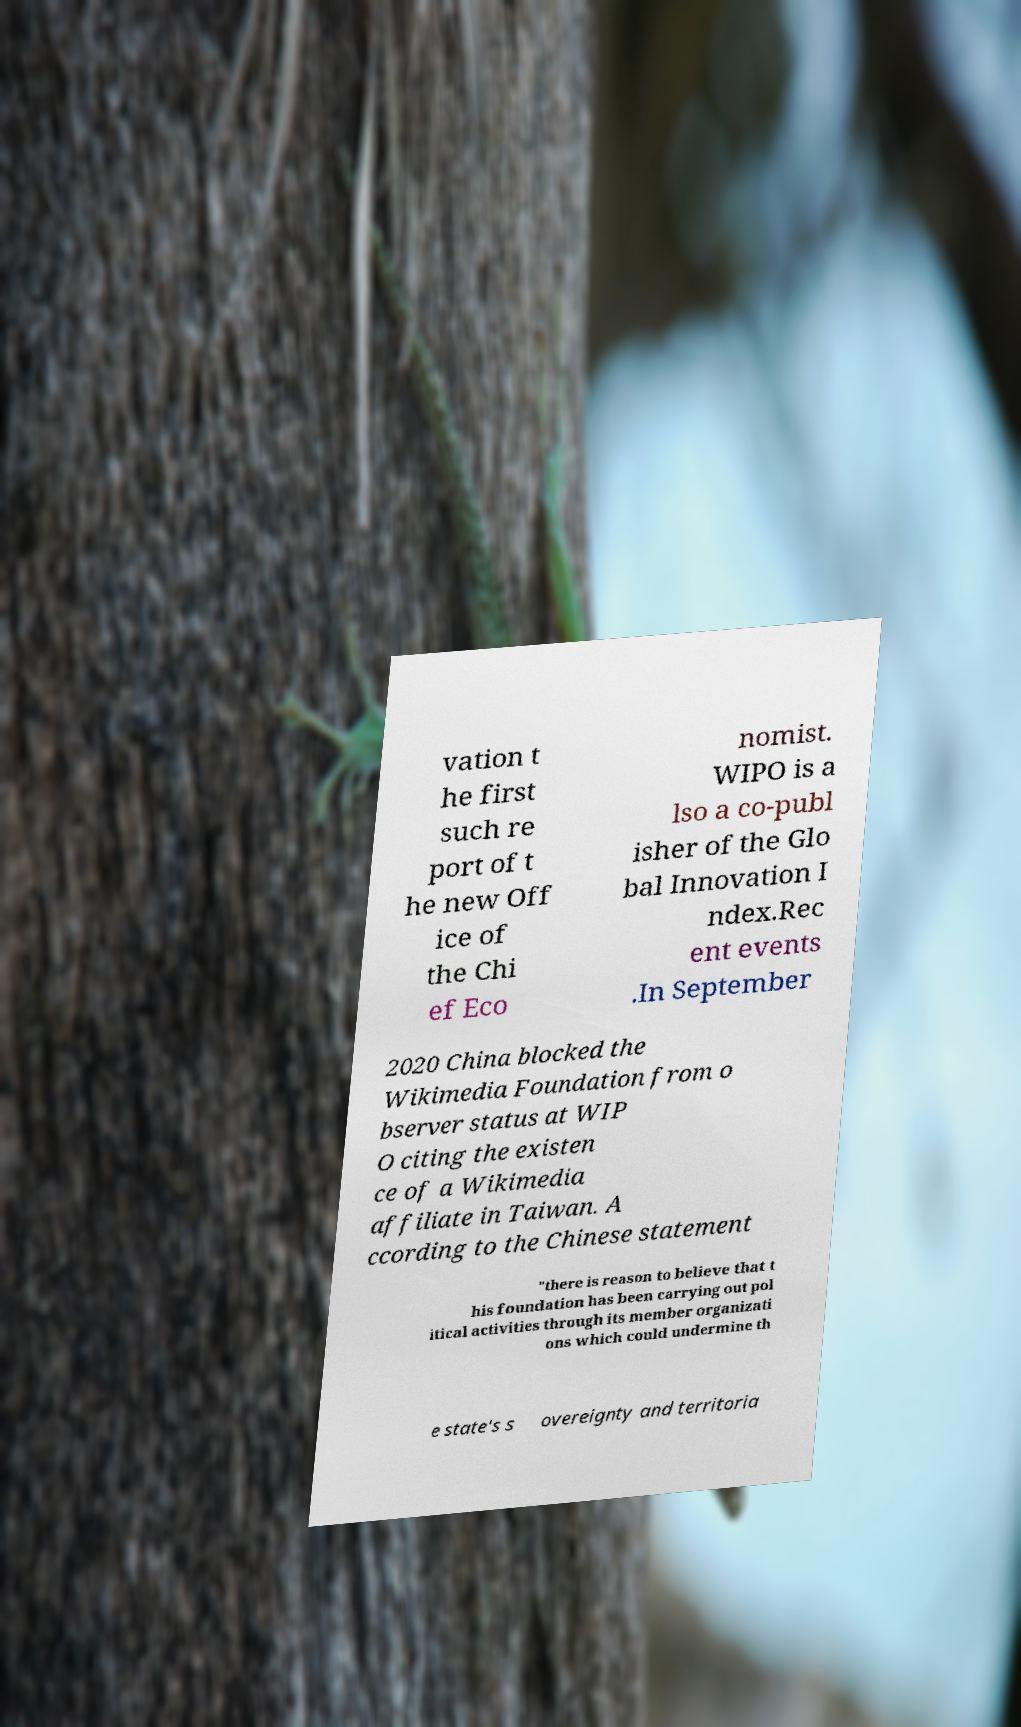Can you accurately transcribe the text from the provided image for me? vation t he first such re port of t he new Off ice of the Chi ef Eco nomist. WIPO is a lso a co-publ isher of the Glo bal Innovation I ndex.Rec ent events .In September 2020 China blocked the Wikimedia Foundation from o bserver status at WIP O citing the existen ce of a Wikimedia affiliate in Taiwan. A ccording to the Chinese statement "there is reason to believe that t his foundation has been carrying out pol itical activities through its member organizati ons which could undermine th e state's s overeignty and territoria 